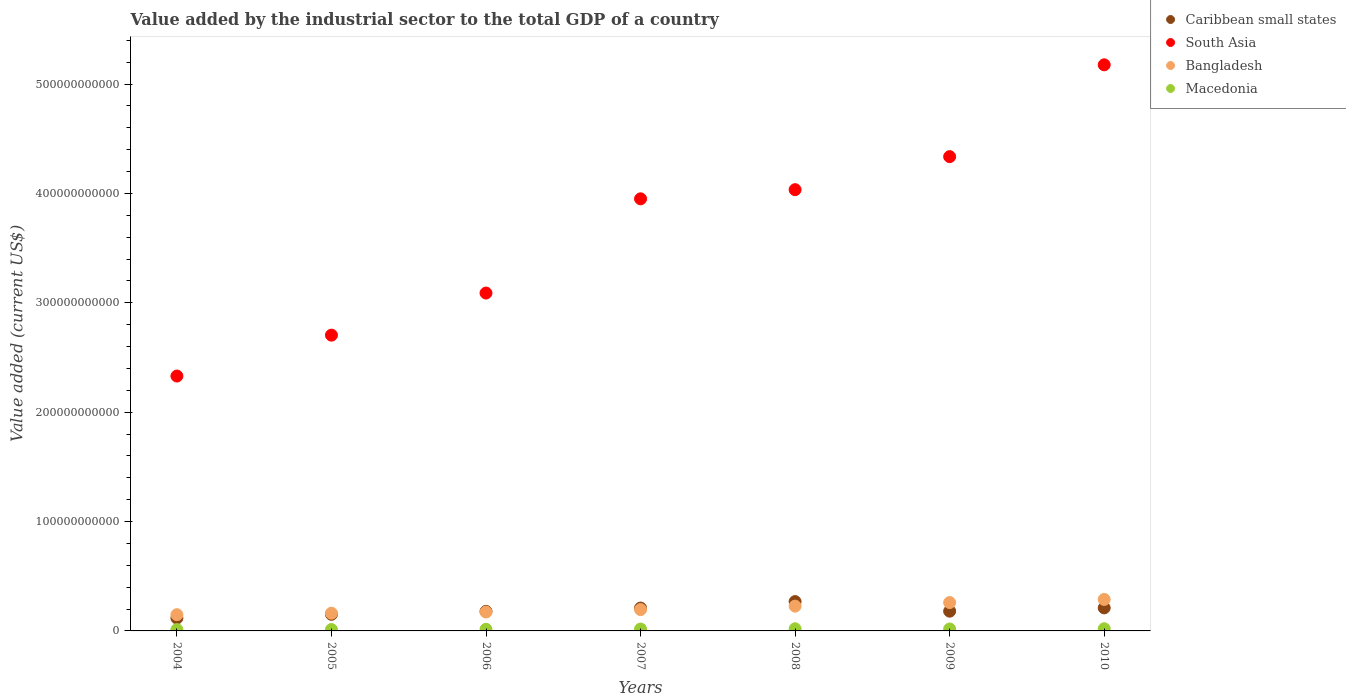Is the number of dotlines equal to the number of legend labels?
Make the answer very short. Yes. What is the value added by the industrial sector to the total GDP in Macedonia in 2007?
Offer a terse response. 1.72e+09. Across all years, what is the maximum value added by the industrial sector to the total GDP in South Asia?
Your answer should be compact. 5.18e+11. Across all years, what is the minimum value added by the industrial sector to the total GDP in Caribbean small states?
Your response must be concise. 1.17e+1. In which year was the value added by the industrial sector to the total GDP in South Asia maximum?
Provide a succinct answer. 2010. What is the total value added by the industrial sector to the total GDP in Bangladesh in the graph?
Your answer should be compact. 1.45e+11. What is the difference between the value added by the industrial sector to the total GDP in Macedonia in 2008 and that in 2010?
Give a very brief answer. -4.39e+07. What is the difference between the value added by the industrial sector to the total GDP in Bangladesh in 2004 and the value added by the industrial sector to the total GDP in Macedonia in 2010?
Ensure brevity in your answer.  1.29e+1. What is the average value added by the industrial sector to the total GDP in Macedonia per year?
Offer a very short reply. 1.62e+09. In the year 2010, what is the difference between the value added by the industrial sector to the total GDP in Macedonia and value added by the industrial sector to the total GDP in South Asia?
Keep it short and to the point. -5.16e+11. What is the ratio of the value added by the industrial sector to the total GDP in Caribbean small states in 2004 to that in 2010?
Ensure brevity in your answer.  0.56. Is the value added by the industrial sector to the total GDP in South Asia in 2004 less than that in 2009?
Provide a short and direct response. Yes. What is the difference between the highest and the second highest value added by the industrial sector to the total GDP in Caribbean small states?
Offer a very short reply. 5.76e+09. What is the difference between the highest and the lowest value added by the industrial sector to the total GDP in Bangladesh?
Provide a succinct answer. 1.39e+1. In how many years, is the value added by the industrial sector to the total GDP in South Asia greater than the average value added by the industrial sector to the total GDP in South Asia taken over all years?
Offer a terse response. 4. Does the value added by the industrial sector to the total GDP in South Asia monotonically increase over the years?
Give a very brief answer. Yes. Is the value added by the industrial sector to the total GDP in Caribbean small states strictly less than the value added by the industrial sector to the total GDP in South Asia over the years?
Make the answer very short. Yes. What is the difference between two consecutive major ticks on the Y-axis?
Your answer should be compact. 1.00e+11. Where does the legend appear in the graph?
Give a very brief answer. Top right. How many legend labels are there?
Your answer should be very brief. 4. What is the title of the graph?
Give a very brief answer. Value added by the industrial sector to the total GDP of a country. What is the label or title of the Y-axis?
Keep it short and to the point. Value added (current US$). What is the Value added (current US$) of Caribbean small states in 2004?
Ensure brevity in your answer.  1.17e+1. What is the Value added (current US$) of South Asia in 2004?
Keep it short and to the point. 2.33e+11. What is the Value added (current US$) in Bangladesh in 2004?
Your answer should be very brief. 1.48e+1. What is the Value added (current US$) of Macedonia in 2004?
Keep it short and to the point. 1.20e+09. What is the Value added (current US$) in Caribbean small states in 2005?
Keep it short and to the point. 1.52e+1. What is the Value added (current US$) of South Asia in 2005?
Your answer should be compact. 2.70e+11. What is the Value added (current US$) of Bangladesh in 2005?
Offer a terse response. 1.62e+1. What is the Value added (current US$) of Macedonia in 2005?
Provide a succinct answer. 1.27e+09. What is the Value added (current US$) in Caribbean small states in 2006?
Offer a terse response. 1.79e+1. What is the Value added (current US$) in South Asia in 2006?
Provide a short and direct response. 3.09e+11. What is the Value added (current US$) of Bangladesh in 2006?
Give a very brief answer. 1.73e+1. What is the Value added (current US$) in Macedonia in 2006?
Keep it short and to the point. 1.49e+09. What is the Value added (current US$) of Caribbean small states in 2007?
Your answer should be very brief. 2.09e+1. What is the Value added (current US$) in South Asia in 2007?
Give a very brief answer. 3.95e+11. What is the Value added (current US$) of Bangladesh in 2007?
Ensure brevity in your answer.  1.95e+1. What is the Value added (current US$) in Macedonia in 2007?
Make the answer very short. 1.72e+09. What is the Value added (current US$) in Caribbean small states in 2008?
Make the answer very short. 2.68e+1. What is the Value added (current US$) of South Asia in 2008?
Ensure brevity in your answer.  4.03e+11. What is the Value added (current US$) in Bangladesh in 2008?
Provide a short and direct response. 2.27e+1. What is the Value added (current US$) of Macedonia in 2008?
Your response must be concise. 1.94e+09. What is the Value added (current US$) in Caribbean small states in 2009?
Ensure brevity in your answer.  1.80e+1. What is the Value added (current US$) in South Asia in 2009?
Offer a terse response. 4.34e+11. What is the Value added (current US$) in Bangladesh in 2009?
Offer a terse response. 2.59e+1. What is the Value added (current US$) of Macedonia in 2009?
Keep it short and to the point. 1.78e+09. What is the Value added (current US$) in Caribbean small states in 2010?
Keep it short and to the point. 2.10e+1. What is the Value added (current US$) in South Asia in 2010?
Provide a short and direct response. 5.18e+11. What is the Value added (current US$) of Bangladesh in 2010?
Keep it short and to the point. 2.88e+1. What is the Value added (current US$) of Macedonia in 2010?
Provide a short and direct response. 1.98e+09. Across all years, what is the maximum Value added (current US$) in Caribbean small states?
Keep it short and to the point. 2.68e+1. Across all years, what is the maximum Value added (current US$) in South Asia?
Your response must be concise. 5.18e+11. Across all years, what is the maximum Value added (current US$) in Bangladesh?
Provide a short and direct response. 2.88e+1. Across all years, what is the maximum Value added (current US$) of Macedonia?
Give a very brief answer. 1.98e+09. Across all years, what is the minimum Value added (current US$) in Caribbean small states?
Provide a succinct answer. 1.17e+1. Across all years, what is the minimum Value added (current US$) in South Asia?
Give a very brief answer. 2.33e+11. Across all years, what is the minimum Value added (current US$) of Bangladesh?
Your response must be concise. 1.48e+1. Across all years, what is the minimum Value added (current US$) in Macedonia?
Offer a terse response. 1.20e+09. What is the total Value added (current US$) of Caribbean small states in the graph?
Your response must be concise. 1.32e+11. What is the total Value added (current US$) of South Asia in the graph?
Offer a very short reply. 2.56e+12. What is the total Value added (current US$) in Bangladesh in the graph?
Offer a very short reply. 1.45e+11. What is the total Value added (current US$) of Macedonia in the graph?
Offer a terse response. 1.14e+1. What is the difference between the Value added (current US$) of Caribbean small states in 2004 and that in 2005?
Your answer should be compact. -3.45e+09. What is the difference between the Value added (current US$) in South Asia in 2004 and that in 2005?
Make the answer very short. -3.74e+1. What is the difference between the Value added (current US$) of Bangladesh in 2004 and that in 2005?
Your answer should be compact. -1.35e+09. What is the difference between the Value added (current US$) of Macedonia in 2004 and that in 2005?
Your answer should be very brief. -7.88e+07. What is the difference between the Value added (current US$) in Caribbean small states in 2004 and that in 2006?
Your answer should be compact. -6.18e+09. What is the difference between the Value added (current US$) in South Asia in 2004 and that in 2006?
Give a very brief answer. -7.59e+1. What is the difference between the Value added (current US$) in Bangladesh in 2004 and that in 2006?
Provide a short and direct response. -2.47e+09. What is the difference between the Value added (current US$) in Macedonia in 2004 and that in 2006?
Your response must be concise. -2.91e+08. What is the difference between the Value added (current US$) of Caribbean small states in 2004 and that in 2007?
Your response must be concise. -9.18e+09. What is the difference between the Value added (current US$) in South Asia in 2004 and that in 2007?
Your answer should be very brief. -1.62e+11. What is the difference between the Value added (current US$) of Bangladesh in 2004 and that in 2007?
Provide a short and direct response. -4.67e+09. What is the difference between the Value added (current US$) of Macedonia in 2004 and that in 2007?
Provide a short and direct response. -5.20e+08. What is the difference between the Value added (current US$) in Caribbean small states in 2004 and that in 2008?
Give a very brief answer. -1.51e+1. What is the difference between the Value added (current US$) in South Asia in 2004 and that in 2008?
Ensure brevity in your answer.  -1.70e+11. What is the difference between the Value added (current US$) in Bangladesh in 2004 and that in 2008?
Keep it short and to the point. -7.83e+09. What is the difference between the Value added (current US$) of Macedonia in 2004 and that in 2008?
Your answer should be compact. -7.40e+08. What is the difference between the Value added (current US$) of Caribbean small states in 2004 and that in 2009?
Offer a very short reply. -6.32e+09. What is the difference between the Value added (current US$) of South Asia in 2004 and that in 2009?
Keep it short and to the point. -2.01e+11. What is the difference between the Value added (current US$) in Bangladesh in 2004 and that in 2009?
Make the answer very short. -1.11e+1. What is the difference between the Value added (current US$) in Macedonia in 2004 and that in 2009?
Give a very brief answer. -5.88e+08. What is the difference between the Value added (current US$) of Caribbean small states in 2004 and that in 2010?
Make the answer very short. -9.32e+09. What is the difference between the Value added (current US$) in South Asia in 2004 and that in 2010?
Your response must be concise. -2.85e+11. What is the difference between the Value added (current US$) of Bangladesh in 2004 and that in 2010?
Your answer should be compact. -1.39e+1. What is the difference between the Value added (current US$) in Macedonia in 2004 and that in 2010?
Offer a very short reply. -7.84e+08. What is the difference between the Value added (current US$) of Caribbean small states in 2005 and that in 2006?
Give a very brief answer. -2.74e+09. What is the difference between the Value added (current US$) in South Asia in 2005 and that in 2006?
Your answer should be very brief. -3.85e+1. What is the difference between the Value added (current US$) of Bangladesh in 2005 and that in 2006?
Your answer should be very brief. -1.12e+09. What is the difference between the Value added (current US$) in Macedonia in 2005 and that in 2006?
Your response must be concise. -2.12e+08. What is the difference between the Value added (current US$) in Caribbean small states in 2005 and that in 2007?
Provide a short and direct response. -5.74e+09. What is the difference between the Value added (current US$) in South Asia in 2005 and that in 2007?
Your answer should be very brief. -1.25e+11. What is the difference between the Value added (current US$) in Bangladesh in 2005 and that in 2007?
Provide a short and direct response. -3.33e+09. What is the difference between the Value added (current US$) in Macedonia in 2005 and that in 2007?
Your response must be concise. -4.41e+08. What is the difference between the Value added (current US$) in Caribbean small states in 2005 and that in 2008?
Your answer should be very brief. -1.16e+1. What is the difference between the Value added (current US$) in South Asia in 2005 and that in 2008?
Give a very brief answer. -1.33e+11. What is the difference between the Value added (current US$) of Bangladesh in 2005 and that in 2008?
Ensure brevity in your answer.  -6.48e+09. What is the difference between the Value added (current US$) of Macedonia in 2005 and that in 2008?
Provide a short and direct response. -6.61e+08. What is the difference between the Value added (current US$) of Caribbean small states in 2005 and that in 2009?
Offer a terse response. -2.87e+09. What is the difference between the Value added (current US$) of South Asia in 2005 and that in 2009?
Your answer should be very brief. -1.63e+11. What is the difference between the Value added (current US$) of Bangladesh in 2005 and that in 2009?
Give a very brief answer. -9.74e+09. What is the difference between the Value added (current US$) of Macedonia in 2005 and that in 2009?
Your response must be concise. -5.09e+08. What is the difference between the Value added (current US$) of Caribbean small states in 2005 and that in 2010?
Make the answer very short. -5.88e+09. What is the difference between the Value added (current US$) of South Asia in 2005 and that in 2010?
Your response must be concise. -2.47e+11. What is the difference between the Value added (current US$) of Bangladesh in 2005 and that in 2010?
Provide a short and direct response. -1.26e+1. What is the difference between the Value added (current US$) of Macedonia in 2005 and that in 2010?
Provide a succinct answer. -7.05e+08. What is the difference between the Value added (current US$) in Caribbean small states in 2006 and that in 2007?
Make the answer very short. -3.00e+09. What is the difference between the Value added (current US$) of South Asia in 2006 and that in 2007?
Make the answer very short. -8.62e+1. What is the difference between the Value added (current US$) of Bangladesh in 2006 and that in 2007?
Give a very brief answer. -2.20e+09. What is the difference between the Value added (current US$) of Macedonia in 2006 and that in 2007?
Give a very brief answer. -2.29e+08. What is the difference between the Value added (current US$) in Caribbean small states in 2006 and that in 2008?
Give a very brief answer. -8.90e+09. What is the difference between the Value added (current US$) of South Asia in 2006 and that in 2008?
Your response must be concise. -9.45e+1. What is the difference between the Value added (current US$) in Bangladesh in 2006 and that in 2008?
Provide a short and direct response. -5.35e+09. What is the difference between the Value added (current US$) in Macedonia in 2006 and that in 2008?
Offer a terse response. -4.49e+08. What is the difference between the Value added (current US$) in Caribbean small states in 2006 and that in 2009?
Give a very brief answer. -1.39e+08. What is the difference between the Value added (current US$) in South Asia in 2006 and that in 2009?
Your response must be concise. -1.25e+11. What is the difference between the Value added (current US$) of Bangladesh in 2006 and that in 2009?
Your answer should be compact. -8.62e+09. What is the difference between the Value added (current US$) in Macedonia in 2006 and that in 2009?
Your answer should be compact. -2.97e+08. What is the difference between the Value added (current US$) in Caribbean small states in 2006 and that in 2010?
Your answer should be very brief. -3.14e+09. What is the difference between the Value added (current US$) of South Asia in 2006 and that in 2010?
Provide a short and direct response. -2.09e+11. What is the difference between the Value added (current US$) of Bangladesh in 2006 and that in 2010?
Offer a very short reply. -1.15e+1. What is the difference between the Value added (current US$) of Macedonia in 2006 and that in 2010?
Offer a very short reply. -4.93e+08. What is the difference between the Value added (current US$) in Caribbean small states in 2007 and that in 2008?
Make the answer very short. -5.90e+09. What is the difference between the Value added (current US$) in South Asia in 2007 and that in 2008?
Ensure brevity in your answer.  -8.36e+09. What is the difference between the Value added (current US$) in Bangladesh in 2007 and that in 2008?
Your response must be concise. -3.15e+09. What is the difference between the Value added (current US$) in Macedonia in 2007 and that in 2008?
Offer a very short reply. -2.20e+08. What is the difference between the Value added (current US$) in Caribbean small states in 2007 and that in 2009?
Your answer should be very brief. 2.86e+09. What is the difference between the Value added (current US$) of South Asia in 2007 and that in 2009?
Offer a terse response. -3.86e+1. What is the difference between the Value added (current US$) of Bangladesh in 2007 and that in 2009?
Offer a terse response. -6.42e+09. What is the difference between the Value added (current US$) in Macedonia in 2007 and that in 2009?
Make the answer very short. -6.80e+07. What is the difference between the Value added (current US$) of Caribbean small states in 2007 and that in 2010?
Make the answer very short. -1.38e+08. What is the difference between the Value added (current US$) of South Asia in 2007 and that in 2010?
Offer a very short reply. -1.23e+11. What is the difference between the Value added (current US$) of Bangladesh in 2007 and that in 2010?
Give a very brief answer. -9.26e+09. What is the difference between the Value added (current US$) of Macedonia in 2007 and that in 2010?
Make the answer very short. -2.64e+08. What is the difference between the Value added (current US$) in Caribbean small states in 2008 and that in 2009?
Ensure brevity in your answer.  8.76e+09. What is the difference between the Value added (current US$) of South Asia in 2008 and that in 2009?
Make the answer very short. -3.02e+1. What is the difference between the Value added (current US$) of Bangladesh in 2008 and that in 2009?
Your answer should be very brief. -3.26e+09. What is the difference between the Value added (current US$) of Macedonia in 2008 and that in 2009?
Keep it short and to the point. 1.52e+08. What is the difference between the Value added (current US$) in Caribbean small states in 2008 and that in 2010?
Your response must be concise. 5.76e+09. What is the difference between the Value added (current US$) of South Asia in 2008 and that in 2010?
Give a very brief answer. -1.14e+11. What is the difference between the Value added (current US$) in Bangladesh in 2008 and that in 2010?
Your answer should be compact. -6.11e+09. What is the difference between the Value added (current US$) in Macedonia in 2008 and that in 2010?
Keep it short and to the point. -4.39e+07. What is the difference between the Value added (current US$) in Caribbean small states in 2009 and that in 2010?
Provide a short and direct response. -3.00e+09. What is the difference between the Value added (current US$) of South Asia in 2009 and that in 2010?
Provide a short and direct response. -8.39e+1. What is the difference between the Value added (current US$) of Bangladesh in 2009 and that in 2010?
Offer a very short reply. -2.85e+09. What is the difference between the Value added (current US$) of Macedonia in 2009 and that in 2010?
Give a very brief answer. -1.96e+08. What is the difference between the Value added (current US$) of Caribbean small states in 2004 and the Value added (current US$) of South Asia in 2005?
Keep it short and to the point. -2.59e+11. What is the difference between the Value added (current US$) of Caribbean small states in 2004 and the Value added (current US$) of Bangladesh in 2005?
Your answer should be very brief. -4.45e+09. What is the difference between the Value added (current US$) in Caribbean small states in 2004 and the Value added (current US$) in Macedonia in 2005?
Offer a very short reply. 1.05e+1. What is the difference between the Value added (current US$) in South Asia in 2004 and the Value added (current US$) in Bangladesh in 2005?
Your answer should be compact. 2.17e+11. What is the difference between the Value added (current US$) in South Asia in 2004 and the Value added (current US$) in Macedonia in 2005?
Your answer should be compact. 2.32e+11. What is the difference between the Value added (current US$) of Bangladesh in 2004 and the Value added (current US$) of Macedonia in 2005?
Keep it short and to the point. 1.36e+1. What is the difference between the Value added (current US$) of Caribbean small states in 2004 and the Value added (current US$) of South Asia in 2006?
Offer a very short reply. -2.97e+11. What is the difference between the Value added (current US$) of Caribbean small states in 2004 and the Value added (current US$) of Bangladesh in 2006?
Keep it short and to the point. -5.58e+09. What is the difference between the Value added (current US$) of Caribbean small states in 2004 and the Value added (current US$) of Macedonia in 2006?
Offer a very short reply. 1.02e+1. What is the difference between the Value added (current US$) of South Asia in 2004 and the Value added (current US$) of Bangladesh in 2006?
Your response must be concise. 2.16e+11. What is the difference between the Value added (current US$) of South Asia in 2004 and the Value added (current US$) of Macedonia in 2006?
Your answer should be very brief. 2.32e+11. What is the difference between the Value added (current US$) in Bangladesh in 2004 and the Value added (current US$) in Macedonia in 2006?
Offer a very short reply. 1.33e+1. What is the difference between the Value added (current US$) of Caribbean small states in 2004 and the Value added (current US$) of South Asia in 2007?
Give a very brief answer. -3.83e+11. What is the difference between the Value added (current US$) in Caribbean small states in 2004 and the Value added (current US$) in Bangladesh in 2007?
Offer a very short reply. -7.78e+09. What is the difference between the Value added (current US$) of Caribbean small states in 2004 and the Value added (current US$) of Macedonia in 2007?
Ensure brevity in your answer.  1.00e+1. What is the difference between the Value added (current US$) of South Asia in 2004 and the Value added (current US$) of Bangladesh in 2007?
Ensure brevity in your answer.  2.14e+11. What is the difference between the Value added (current US$) in South Asia in 2004 and the Value added (current US$) in Macedonia in 2007?
Make the answer very short. 2.31e+11. What is the difference between the Value added (current US$) in Bangladesh in 2004 and the Value added (current US$) in Macedonia in 2007?
Provide a succinct answer. 1.31e+1. What is the difference between the Value added (current US$) of Caribbean small states in 2004 and the Value added (current US$) of South Asia in 2008?
Keep it short and to the point. -3.92e+11. What is the difference between the Value added (current US$) in Caribbean small states in 2004 and the Value added (current US$) in Bangladesh in 2008?
Offer a very short reply. -1.09e+1. What is the difference between the Value added (current US$) in Caribbean small states in 2004 and the Value added (current US$) in Macedonia in 2008?
Provide a short and direct response. 9.79e+09. What is the difference between the Value added (current US$) in South Asia in 2004 and the Value added (current US$) in Bangladesh in 2008?
Ensure brevity in your answer.  2.10e+11. What is the difference between the Value added (current US$) in South Asia in 2004 and the Value added (current US$) in Macedonia in 2008?
Offer a very short reply. 2.31e+11. What is the difference between the Value added (current US$) in Bangladesh in 2004 and the Value added (current US$) in Macedonia in 2008?
Provide a succinct answer. 1.29e+1. What is the difference between the Value added (current US$) in Caribbean small states in 2004 and the Value added (current US$) in South Asia in 2009?
Keep it short and to the point. -4.22e+11. What is the difference between the Value added (current US$) of Caribbean small states in 2004 and the Value added (current US$) of Bangladesh in 2009?
Offer a very short reply. -1.42e+1. What is the difference between the Value added (current US$) of Caribbean small states in 2004 and the Value added (current US$) of Macedonia in 2009?
Make the answer very short. 9.94e+09. What is the difference between the Value added (current US$) in South Asia in 2004 and the Value added (current US$) in Bangladesh in 2009?
Ensure brevity in your answer.  2.07e+11. What is the difference between the Value added (current US$) in South Asia in 2004 and the Value added (current US$) in Macedonia in 2009?
Provide a short and direct response. 2.31e+11. What is the difference between the Value added (current US$) in Bangladesh in 2004 and the Value added (current US$) in Macedonia in 2009?
Keep it short and to the point. 1.30e+1. What is the difference between the Value added (current US$) in Caribbean small states in 2004 and the Value added (current US$) in South Asia in 2010?
Ensure brevity in your answer.  -5.06e+11. What is the difference between the Value added (current US$) of Caribbean small states in 2004 and the Value added (current US$) of Bangladesh in 2010?
Keep it short and to the point. -1.70e+1. What is the difference between the Value added (current US$) in Caribbean small states in 2004 and the Value added (current US$) in Macedonia in 2010?
Provide a short and direct response. 9.75e+09. What is the difference between the Value added (current US$) of South Asia in 2004 and the Value added (current US$) of Bangladesh in 2010?
Make the answer very short. 2.04e+11. What is the difference between the Value added (current US$) of South Asia in 2004 and the Value added (current US$) of Macedonia in 2010?
Ensure brevity in your answer.  2.31e+11. What is the difference between the Value added (current US$) in Bangladesh in 2004 and the Value added (current US$) in Macedonia in 2010?
Provide a short and direct response. 1.29e+1. What is the difference between the Value added (current US$) in Caribbean small states in 2005 and the Value added (current US$) in South Asia in 2006?
Your answer should be compact. -2.94e+11. What is the difference between the Value added (current US$) in Caribbean small states in 2005 and the Value added (current US$) in Bangladesh in 2006?
Provide a short and direct response. -2.13e+09. What is the difference between the Value added (current US$) of Caribbean small states in 2005 and the Value added (current US$) of Macedonia in 2006?
Ensure brevity in your answer.  1.37e+1. What is the difference between the Value added (current US$) in South Asia in 2005 and the Value added (current US$) in Bangladesh in 2006?
Offer a very short reply. 2.53e+11. What is the difference between the Value added (current US$) in South Asia in 2005 and the Value added (current US$) in Macedonia in 2006?
Your response must be concise. 2.69e+11. What is the difference between the Value added (current US$) of Bangladesh in 2005 and the Value added (current US$) of Macedonia in 2006?
Your answer should be very brief. 1.47e+1. What is the difference between the Value added (current US$) of Caribbean small states in 2005 and the Value added (current US$) of South Asia in 2007?
Offer a very short reply. -3.80e+11. What is the difference between the Value added (current US$) in Caribbean small states in 2005 and the Value added (current US$) in Bangladesh in 2007?
Make the answer very short. -4.33e+09. What is the difference between the Value added (current US$) of Caribbean small states in 2005 and the Value added (current US$) of Macedonia in 2007?
Make the answer very short. 1.35e+1. What is the difference between the Value added (current US$) in South Asia in 2005 and the Value added (current US$) in Bangladesh in 2007?
Provide a succinct answer. 2.51e+11. What is the difference between the Value added (current US$) in South Asia in 2005 and the Value added (current US$) in Macedonia in 2007?
Keep it short and to the point. 2.69e+11. What is the difference between the Value added (current US$) of Bangladesh in 2005 and the Value added (current US$) of Macedonia in 2007?
Your response must be concise. 1.45e+1. What is the difference between the Value added (current US$) in Caribbean small states in 2005 and the Value added (current US$) in South Asia in 2008?
Ensure brevity in your answer.  -3.88e+11. What is the difference between the Value added (current US$) in Caribbean small states in 2005 and the Value added (current US$) in Bangladesh in 2008?
Your answer should be compact. -7.48e+09. What is the difference between the Value added (current US$) in Caribbean small states in 2005 and the Value added (current US$) in Macedonia in 2008?
Make the answer very short. 1.32e+1. What is the difference between the Value added (current US$) in South Asia in 2005 and the Value added (current US$) in Bangladesh in 2008?
Provide a short and direct response. 2.48e+11. What is the difference between the Value added (current US$) in South Asia in 2005 and the Value added (current US$) in Macedonia in 2008?
Offer a terse response. 2.68e+11. What is the difference between the Value added (current US$) of Bangladesh in 2005 and the Value added (current US$) of Macedonia in 2008?
Your answer should be very brief. 1.42e+1. What is the difference between the Value added (current US$) of Caribbean small states in 2005 and the Value added (current US$) of South Asia in 2009?
Your response must be concise. -4.18e+11. What is the difference between the Value added (current US$) of Caribbean small states in 2005 and the Value added (current US$) of Bangladesh in 2009?
Your response must be concise. -1.07e+1. What is the difference between the Value added (current US$) of Caribbean small states in 2005 and the Value added (current US$) of Macedonia in 2009?
Your response must be concise. 1.34e+1. What is the difference between the Value added (current US$) of South Asia in 2005 and the Value added (current US$) of Bangladesh in 2009?
Your answer should be very brief. 2.44e+11. What is the difference between the Value added (current US$) in South Asia in 2005 and the Value added (current US$) in Macedonia in 2009?
Provide a short and direct response. 2.69e+11. What is the difference between the Value added (current US$) of Bangladesh in 2005 and the Value added (current US$) of Macedonia in 2009?
Provide a short and direct response. 1.44e+1. What is the difference between the Value added (current US$) of Caribbean small states in 2005 and the Value added (current US$) of South Asia in 2010?
Make the answer very short. -5.02e+11. What is the difference between the Value added (current US$) of Caribbean small states in 2005 and the Value added (current US$) of Bangladesh in 2010?
Give a very brief answer. -1.36e+1. What is the difference between the Value added (current US$) in Caribbean small states in 2005 and the Value added (current US$) in Macedonia in 2010?
Provide a short and direct response. 1.32e+1. What is the difference between the Value added (current US$) in South Asia in 2005 and the Value added (current US$) in Bangladesh in 2010?
Keep it short and to the point. 2.42e+11. What is the difference between the Value added (current US$) of South Asia in 2005 and the Value added (current US$) of Macedonia in 2010?
Offer a very short reply. 2.68e+11. What is the difference between the Value added (current US$) of Bangladesh in 2005 and the Value added (current US$) of Macedonia in 2010?
Offer a terse response. 1.42e+1. What is the difference between the Value added (current US$) of Caribbean small states in 2006 and the Value added (current US$) of South Asia in 2007?
Offer a very short reply. -3.77e+11. What is the difference between the Value added (current US$) of Caribbean small states in 2006 and the Value added (current US$) of Bangladesh in 2007?
Offer a terse response. -1.60e+09. What is the difference between the Value added (current US$) of Caribbean small states in 2006 and the Value added (current US$) of Macedonia in 2007?
Make the answer very short. 1.62e+1. What is the difference between the Value added (current US$) in South Asia in 2006 and the Value added (current US$) in Bangladesh in 2007?
Give a very brief answer. 2.89e+11. What is the difference between the Value added (current US$) of South Asia in 2006 and the Value added (current US$) of Macedonia in 2007?
Offer a very short reply. 3.07e+11. What is the difference between the Value added (current US$) of Bangladesh in 2006 and the Value added (current US$) of Macedonia in 2007?
Make the answer very short. 1.56e+1. What is the difference between the Value added (current US$) in Caribbean small states in 2006 and the Value added (current US$) in South Asia in 2008?
Your answer should be very brief. -3.85e+11. What is the difference between the Value added (current US$) in Caribbean small states in 2006 and the Value added (current US$) in Bangladesh in 2008?
Offer a very short reply. -4.75e+09. What is the difference between the Value added (current US$) in Caribbean small states in 2006 and the Value added (current US$) in Macedonia in 2008?
Your answer should be compact. 1.60e+1. What is the difference between the Value added (current US$) of South Asia in 2006 and the Value added (current US$) of Bangladesh in 2008?
Your answer should be very brief. 2.86e+11. What is the difference between the Value added (current US$) of South Asia in 2006 and the Value added (current US$) of Macedonia in 2008?
Your answer should be very brief. 3.07e+11. What is the difference between the Value added (current US$) of Bangladesh in 2006 and the Value added (current US$) of Macedonia in 2008?
Your answer should be very brief. 1.54e+1. What is the difference between the Value added (current US$) in Caribbean small states in 2006 and the Value added (current US$) in South Asia in 2009?
Make the answer very short. -4.16e+11. What is the difference between the Value added (current US$) of Caribbean small states in 2006 and the Value added (current US$) of Bangladesh in 2009?
Make the answer very short. -8.01e+09. What is the difference between the Value added (current US$) in Caribbean small states in 2006 and the Value added (current US$) in Macedonia in 2009?
Keep it short and to the point. 1.61e+1. What is the difference between the Value added (current US$) in South Asia in 2006 and the Value added (current US$) in Bangladesh in 2009?
Your answer should be compact. 2.83e+11. What is the difference between the Value added (current US$) in South Asia in 2006 and the Value added (current US$) in Macedonia in 2009?
Your answer should be compact. 3.07e+11. What is the difference between the Value added (current US$) of Bangladesh in 2006 and the Value added (current US$) of Macedonia in 2009?
Keep it short and to the point. 1.55e+1. What is the difference between the Value added (current US$) in Caribbean small states in 2006 and the Value added (current US$) in South Asia in 2010?
Your answer should be compact. -5.00e+11. What is the difference between the Value added (current US$) of Caribbean small states in 2006 and the Value added (current US$) of Bangladesh in 2010?
Your answer should be compact. -1.09e+1. What is the difference between the Value added (current US$) in Caribbean small states in 2006 and the Value added (current US$) in Macedonia in 2010?
Make the answer very short. 1.59e+1. What is the difference between the Value added (current US$) of South Asia in 2006 and the Value added (current US$) of Bangladesh in 2010?
Your answer should be very brief. 2.80e+11. What is the difference between the Value added (current US$) of South Asia in 2006 and the Value added (current US$) of Macedonia in 2010?
Ensure brevity in your answer.  3.07e+11. What is the difference between the Value added (current US$) in Bangladesh in 2006 and the Value added (current US$) in Macedonia in 2010?
Ensure brevity in your answer.  1.53e+1. What is the difference between the Value added (current US$) in Caribbean small states in 2007 and the Value added (current US$) in South Asia in 2008?
Ensure brevity in your answer.  -3.82e+11. What is the difference between the Value added (current US$) of Caribbean small states in 2007 and the Value added (current US$) of Bangladesh in 2008?
Your response must be concise. -1.75e+09. What is the difference between the Value added (current US$) in Caribbean small states in 2007 and the Value added (current US$) in Macedonia in 2008?
Provide a short and direct response. 1.90e+1. What is the difference between the Value added (current US$) in South Asia in 2007 and the Value added (current US$) in Bangladesh in 2008?
Offer a very short reply. 3.72e+11. What is the difference between the Value added (current US$) in South Asia in 2007 and the Value added (current US$) in Macedonia in 2008?
Give a very brief answer. 3.93e+11. What is the difference between the Value added (current US$) in Bangladesh in 2007 and the Value added (current US$) in Macedonia in 2008?
Provide a succinct answer. 1.76e+1. What is the difference between the Value added (current US$) of Caribbean small states in 2007 and the Value added (current US$) of South Asia in 2009?
Your answer should be compact. -4.13e+11. What is the difference between the Value added (current US$) of Caribbean small states in 2007 and the Value added (current US$) of Bangladesh in 2009?
Make the answer very short. -5.01e+09. What is the difference between the Value added (current US$) of Caribbean small states in 2007 and the Value added (current US$) of Macedonia in 2009?
Your response must be concise. 1.91e+1. What is the difference between the Value added (current US$) of South Asia in 2007 and the Value added (current US$) of Bangladesh in 2009?
Offer a terse response. 3.69e+11. What is the difference between the Value added (current US$) in South Asia in 2007 and the Value added (current US$) in Macedonia in 2009?
Offer a terse response. 3.93e+11. What is the difference between the Value added (current US$) in Bangladesh in 2007 and the Value added (current US$) in Macedonia in 2009?
Provide a succinct answer. 1.77e+1. What is the difference between the Value added (current US$) of Caribbean small states in 2007 and the Value added (current US$) of South Asia in 2010?
Provide a succinct answer. -4.97e+11. What is the difference between the Value added (current US$) in Caribbean small states in 2007 and the Value added (current US$) in Bangladesh in 2010?
Your response must be concise. -7.86e+09. What is the difference between the Value added (current US$) of Caribbean small states in 2007 and the Value added (current US$) of Macedonia in 2010?
Your answer should be compact. 1.89e+1. What is the difference between the Value added (current US$) of South Asia in 2007 and the Value added (current US$) of Bangladesh in 2010?
Offer a very short reply. 3.66e+11. What is the difference between the Value added (current US$) of South Asia in 2007 and the Value added (current US$) of Macedonia in 2010?
Offer a very short reply. 3.93e+11. What is the difference between the Value added (current US$) of Bangladesh in 2007 and the Value added (current US$) of Macedonia in 2010?
Provide a succinct answer. 1.75e+1. What is the difference between the Value added (current US$) in Caribbean small states in 2008 and the Value added (current US$) in South Asia in 2009?
Give a very brief answer. -4.07e+11. What is the difference between the Value added (current US$) in Caribbean small states in 2008 and the Value added (current US$) in Bangladesh in 2009?
Offer a terse response. 8.88e+08. What is the difference between the Value added (current US$) of Caribbean small states in 2008 and the Value added (current US$) of Macedonia in 2009?
Provide a short and direct response. 2.50e+1. What is the difference between the Value added (current US$) of South Asia in 2008 and the Value added (current US$) of Bangladesh in 2009?
Your answer should be very brief. 3.77e+11. What is the difference between the Value added (current US$) of South Asia in 2008 and the Value added (current US$) of Macedonia in 2009?
Give a very brief answer. 4.02e+11. What is the difference between the Value added (current US$) of Bangladesh in 2008 and the Value added (current US$) of Macedonia in 2009?
Make the answer very short. 2.09e+1. What is the difference between the Value added (current US$) of Caribbean small states in 2008 and the Value added (current US$) of South Asia in 2010?
Keep it short and to the point. -4.91e+11. What is the difference between the Value added (current US$) in Caribbean small states in 2008 and the Value added (current US$) in Bangladesh in 2010?
Your answer should be compact. -1.96e+09. What is the difference between the Value added (current US$) in Caribbean small states in 2008 and the Value added (current US$) in Macedonia in 2010?
Offer a terse response. 2.48e+1. What is the difference between the Value added (current US$) of South Asia in 2008 and the Value added (current US$) of Bangladesh in 2010?
Give a very brief answer. 3.75e+11. What is the difference between the Value added (current US$) of South Asia in 2008 and the Value added (current US$) of Macedonia in 2010?
Offer a terse response. 4.01e+11. What is the difference between the Value added (current US$) in Bangladesh in 2008 and the Value added (current US$) in Macedonia in 2010?
Provide a succinct answer. 2.07e+1. What is the difference between the Value added (current US$) in Caribbean small states in 2009 and the Value added (current US$) in South Asia in 2010?
Provide a short and direct response. -4.99e+11. What is the difference between the Value added (current US$) of Caribbean small states in 2009 and the Value added (current US$) of Bangladesh in 2010?
Make the answer very short. -1.07e+1. What is the difference between the Value added (current US$) of Caribbean small states in 2009 and the Value added (current US$) of Macedonia in 2010?
Keep it short and to the point. 1.61e+1. What is the difference between the Value added (current US$) of South Asia in 2009 and the Value added (current US$) of Bangladesh in 2010?
Your response must be concise. 4.05e+11. What is the difference between the Value added (current US$) in South Asia in 2009 and the Value added (current US$) in Macedonia in 2010?
Offer a terse response. 4.32e+11. What is the difference between the Value added (current US$) in Bangladesh in 2009 and the Value added (current US$) in Macedonia in 2010?
Your answer should be compact. 2.39e+1. What is the average Value added (current US$) of Caribbean small states per year?
Offer a very short reply. 1.88e+1. What is the average Value added (current US$) of South Asia per year?
Provide a short and direct response. 3.66e+11. What is the average Value added (current US$) in Bangladesh per year?
Your answer should be very brief. 2.07e+1. What is the average Value added (current US$) in Macedonia per year?
Offer a very short reply. 1.62e+09. In the year 2004, what is the difference between the Value added (current US$) of Caribbean small states and Value added (current US$) of South Asia?
Provide a short and direct response. -2.21e+11. In the year 2004, what is the difference between the Value added (current US$) in Caribbean small states and Value added (current US$) in Bangladesh?
Give a very brief answer. -3.10e+09. In the year 2004, what is the difference between the Value added (current US$) in Caribbean small states and Value added (current US$) in Macedonia?
Make the answer very short. 1.05e+1. In the year 2004, what is the difference between the Value added (current US$) in South Asia and Value added (current US$) in Bangladesh?
Your response must be concise. 2.18e+11. In the year 2004, what is the difference between the Value added (current US$) in South Asia and Value added (current US$) in Macedonia?
Provide a succinct answer. 2.32e+11. In the year 2004, what is the difference between the Value added (current US$) of Bangladesh and Value added (current US$) of Macedonia?
Your answer should be very brief. 1.36e+1. In the year 2005, what is the difference between the Value added (current US$) in Caribbean small states and Value added (current US$) in South Asia?
Your answer should be compact. -2.55e+11. In the year 2005, what is the difference between the Value added (current US$) in Caribbean small states and Value added (current US$) in Bangladesh?
Your response must be concise. -1.01e+09. In the year 2005, what is the difference between the Value added (current US$) in Caribbean small states and Value added (current US$) in Macedonia?
Your answer should be compact. 1.39e+1. In the year 2005, what is the difference between the Value added (current US$) of South Asia and Value added (current US$) of Bangladesh?
Your response must be concise. 2.54e+11. In the year 2005, what is the difference between the Value added (current US$) in South Asia and Value added (current US$) in Macedonia?
Make the answer very short. 2.69e+11. In the year 2005, what is the difference between the Value added (current US$) of Bangladesh and Value added (current US$) of Macedonia?
Give a very brief answer. 1.49e+1. In the year 2006, what is the difference between the Value added (current US$) of Caribbean small states and Value added (current US$) of South Asia?
Your answer should be very brief. -2.91e+11. In the year 2006, what is the difference between the Value added (current US$) of Caribbean small states and Value added (current US$) of Bangladesh?
Provide a succinct answer. 6.04e+08. In the year 2006, what is the difference between the Value added (current US$) of Caribbean small states and Value added (current US$) of Macedonia?
Offer a terse response. 1.64e+1. In the year 2006, what is the difference between the Value added (current US$) of South Asia and Value added (current US$) of Bangladesh?
Make the answer very short. 2.92e+11. In the year 2006, what is the difference between the Value added (current US$) in South Asia and Value added (current US$) in Macedonia?
Ensure brevity in your answer.  3.07e+11. In the year 2006, what is the difference between the Value added (current US$) in Bangladesh and Value added (current US$) in Macedonia?
Offer a terse response. 1.58e+1. In the year 2007, what is the difference between the Value added (current US$) in Caribbean small states and Value added (current US$) in South Asia?
Your answer should be very brief. -3.74e+11. In the year 2007, what is the difference between the Value added (current US$) in Caribbean small states and Value added (current US$) in Bangladesh?
Give a very brief answer. 1.41e+09. In the year 2007, what is the difference between the Value added (current US$) of Caribbean small states and Value added (current US$) of Macedonia?
Offer a terse response. 1.92e+1. In the year 2007, what is the difference between the Value added (current US$) in South Asia and Value added (current US$) in Bangladesh?
Make the answer very short. 3.76e+11. In the year 2007, what is the difference between the Value added (current US$) in South Asia and Value added (current US$) in Macedonia?
Make the answer very short. 3.93e+11. In the year 2007, what is the difference between the Value added (current US$) of Bangladesh and Value added (current US$) of Macedonia?
Your answer should be very brief. 1.78e+1. In the year 2008, what is the difference between the Value added (current US$) in Caribbean small states and Value added (current US$) in South Asia?
Give a very brief answer. -3.77e+11. In the year 2008, what is the difference between the Value added (current US$) of Caribbean small states and Value added (current US$) of Bangladesh?
Make the answer very short. 4.15e+09. In the year 2008, what is the difference between the Value added (current US$) of Caribbean small states and Value added (current US$) of Macedonia?
Provide a succinct answer. 2.49e+1. In the year 2008, what is the difference between the Value added (current US$) of South Asia and Value added (current US$) of Bangladesh?
Provide a short and direct response. 3.81e+11. In the year 2008, what is the difference between the Value added (current US$) in South Asia and Value added (current US$) in Macedonia?
Your response must be concise. 4.01e+11. In the year 2008, what is the difference between the Value added (current US$) in Bangladesh and Value added (current US$) in Macedonia?
Make the answer very short. 2.07e+1. In the year 2009, what is the difference between the Value added (current US$) in Caribbean small states and Value added (current US$) in South Asia?
Ensure brevity in your answer.  -4.16e+11. In the year 2009, what is the difference between the Value added (current US$) of Caribbean small states and Value added (current US$) of Bangladesh?
Offer a very short reply. -7.87e+09. In the year 2009, what is the difference between the Value added (current US$) in Caribbean small states and Value added (current US$) in Macedonia?
Give a very brief answer. 1.63e+1. In the year 2009, what is the difference between the Value added (current US$) in South Asia and Value added (current US$) in Bangladesh?
Offer a very short reply. 4.08e+11. In the year 2009, what is the difference between the Value added (current US$) in South Asia and Value added (current US$) in Macedonia?
Keep it short and to the point. 4.32e+11. In the year 2009, what is the difference between the Value added (current US$) of Bangladesh and Value added (current US$) of Macedonia?
Provide a succinct answer. 2.41e+1. In the year 2010, what is the difference between the Value added (current US$) in Caribbean small states and Value added (current US$) in South Asia?
Provide a succinct answer. -4.96e+11. In the year 2010, what is the difference between the Value added (current US$) of Caribbean small states and Value added (current US$) of Bangladesh?
Your response must be concise. -7.72e+09. In the year 2010, what is the difference between the Value added (current US$) in Caribbean small states and Value added (current US$) in Macedonia?
Give a very brief answer. 1.91e+1. In the year 2010, what is the difference between the Value added (current US$) of South Asia and Value added (current US$) of Bangladesh?
Offer a very short reply. 4.89e+11. In the year 2010, what is the difference between the Value added (current US$) in South Asia and Value added (current US$) in Macedonia?
Your answer should be very brief. 5.16e+11. In the year 2010, what is the difference between the Value added (current US$) of Bangladesh and Value added (current US$) of Macedonia?
Your answer should be compact. 2.68e+1. What is the ratio of the Value added (current US$) of Caribbean small states in 2004 to that in 2005?
Make the answer very short. 0.77. What is the ratio of the Value added (current US$) of South Asia in 2004 to that in 2005?
Provide a succinct answer. 0.86. What is the ratio of the Value added (current US$) of Bangladesh in 2004 to that in 2005?
Your response must be concise. 0.92. What is the ratio of the Value added (current US$) of Macedonia in 2004 to that in 2005?
Give a very brief answer. 0.94. What is the ratio of the Value added (current US$) in Caribbean small states in 2004 to that in 2006?
Your response must be concise. 0.65. What is the ratio of the Value added (current US$) of South Asia in 2004 to that in 2006?
Keep it short and to the point. 0.75. What is the ratio of the Value added (current US$) of Bangladesh in 2004 to that in 2006?
Offer a very short reply. 0.86. What is the ratio of the Value added (current US$) of Macedonia in 2004 to that in 2006?
Provide a short and direct response. 0.8. What is the ratio of the Value added (current US$) in Caribbean small states in 2004 to that in 2007?
Keep it short and to the point. 0.56. What is the ratio of the Value added (current US$) of South Asia in 2004 to that in 2007?
Make the answer very short. 0.59. What is the ratio of the Value added (current US$) in Bangladesh in 2004 to that in 2007?
Your answer should be compact. 0.76. What is the ratio of the Value added (current US$) of Macedonia in 2004 to that in 2007?
Ensure brevity in your answer.  0.7. What is the ratio of the Value added (current US$) of Caribbean small states in 2004 to that in 2008?
Your answer should be compact. 0.44. What is the ratio of the Value added (current US$) of South Asia in 2004 to that in 2008?
Make the answer very short. 0.58. What is the ratio of the Value added (current US$) in Bangladesh in 2004 to that in 2008?
Your answer should be very brief. 0.65. What is the ratio of the Value added (current US$) in Macedonia in 2004 to that in 2008?
Your response must be concise. 0.62. What is the ratio of the Value added (current US$) of Caribbean small states in 2004 to that in 2009?
Offer a very short reply. 0.65. What is the ratio of the Value added (current US$) in South Asia in 2004 to that in 2009?
Give a very brief answer. 0.54. What is the ratio of the Value added (current US$) of Bangladesh in 2004 to that in 2009?
Provide a short and direct response. 0.57. What is the ratio of the Value added (current US$) of Macedonia in 2004 to that in 2009?
Keep it short and to the point. 0.67. What is the ratio of the Value added (current US$) of Caribbean small states in 2004 to that in 2010?
Give a very brief answer. 0.56. What is the ratio of the Value added (current US$) of South Asia in 2004 to that in 2010?
Ensure brevity in your answer.  0.45. What is the ratio of the Value added (current US$) of Bangladesh in 2004 to that in 2010?
Your answer should be compact. 0.52. What is the ratio of the Value added (current US$) in Macedonia in 2004 to that in 2010?
Keep it short and to the point. 0.6. What is the ratio of the Value added (current US$) in Caribbean small states in 2005 to that in 2006?
Provide a succinct answer. 0.85. What is the ratio of the Value added (current US$) in South Asia in 2005 to that in 2006?
Your response must be concise. 0.88. What is the ratio of the Value added (current US$) of Bangladesh in 2005 to that in 2006?
Your answer should be very brief. 0.94. What is the ratio of the Value added (current US$) in Macedonia in 2005 to that in 2006?
Keep it short and to the point. 0.86. What is the ratio of the Value added (current US$) of Caribbean small states in 2005 to that in 2007?
Ensure brevity in your answer.  0.73. What is the ratio of the Value added (current US$) in South Asia in 2005 to that in 2007?
Keep it short and to the point. 0.68. What is the ratio of the Value added (current US$) in Bangladesh in 2005 to that in 2007?
Provide a short and direct response. 0.83. What is the ratio of the Value added (current US$) in Macedonia in 2005 to that in 2007?
Provide a succinct answer. 0.74. What is the ratio of the Value added (current US$) of Caribbean small states in 2005 to that in 2008?
Offer a very short reply. 0.57. What is the ratio of the Value added (current US$) in South Asia in 2005 to that in 2008?
Make the answer very short. 0.67. What is the ratio of the Value added (current US$) in Bangladesh in 2005 to that in 2008?
Your answer should be very brief. 0.71. What is the ratio of the Value added (current US$) in Macedonia in 2005 to that in 2008?
Offer a very short reply. 0.66. What is the ratio of the Value added (current US$) of Caribbean small states in 2005 to that in 2009?
Your answer should be very brief. 0.84. What is the ratio of the Value added (current US$) in South Asia in 2005 to that in 2009?
Your answer should be very brief. 0.62. What is the ratio of the Value added (current US$) in Bangladesh in 2005 to that in 2009?
Provide a succinct answer. 0.62. What is the ratio of the Value added (current US$) in Macedonia in 2005 to that in 2009?
Your answer should be compact. 0.71. What is the ratio of the Value added (current US$) in Caribbean small states in 2005 to that in 2010?
Make the answer very short. 0.72. What is the ratio of the Value added (current US$) in South Asia in 2005 to that in 2010?
Your answer should be compact. 0.52. What is the ratio of the Value added (current US$) in Bangladesh in 2005 to that in 2010?
Ensure brevity in your answer.  0.56. What is the ratio of the Value added (current US$) of Macedonia in 2005 to that in 2010?
Your answer should be compact. 0.64. What is the ratio of the Value added (current US$) of Caribbean small states in 2006 to that in 2007?
Ensure brevity in your answer.  0.86. What is the ratio of the Value added (current US$) of South Asia in 2006 to that in 2007?
Keep it short and to the point. 0.78. What is the ratio of the Value added (current US$) of Bangladesh in 2006 to that in 2007?
Offer a terse response. 0.89. What is the ratio of the Value added (current US$) of Macedonia in 2006 to that in 2007?
Ensure brevity in your answer.  0.87. What is the ratio of the Value added (current US$) of Caribbean small states in 2006 to that in 2008?
Make the answer very short. 0.67. What is the ratio of the Value added (current US$) of South Asia in 2006 to that in 2008?
Offer a terse response. 0.77. What is the ratio of the Value added (current US$) in Bangladesh in 2006 to that in 2008?
Ensure brevity in your answer.  0.76. What is the ratio of the Value added (current US$) in Macedonia in 2006 to that in 2008?
Provide a succinct answer. 0.77. What is the ratio of the Value added (current US$) in South Asia in 2006 to that in 2009?
Give a very brief answer. 0.71. What is the ratio of the Value added (current US$) of Bangladesh in 2006 to that in 2009?
Offer a very short reply. 0.67. What is the ratio of the Value added (current US$) in Macedonia in 2006 to that in 2009?
Ensure brevity in your answer.  0.83. What is the ratio of the Value added (current US$) of Caribbean small states in 2006 to that in 2010?
Your answer should be very brief. 0.85. What is the ratio of the Value added (current US$) of South Asia in 2006 to that in 2010?
Provide a succinct answer. 0.6. What is the ratio of the Value added (current US$) of Bangladesh in 2006 to that in 2010?
Ensure brevity in your answer.  0.6. What is the ratio of the Value added (current US$) of Macedonia in 2006 to that in 2010?
Provide a short and direct response. 0.75. What is the ratio of the Value added (current US$) in Caribbean small states in 2007 to that in 2008?
Give a very brief answer. 0.78. What is the ratio of the Value added (current US$) of South Asia in 2007 to that in 2008?
Provide a short and direct response. 0.98. What is the ratio of the Value added (current US$) of Bangladesh in 2007 to that in 2008?
Give a very brief answer. 0.86. What is the ratio of the Value added (current US$) of Macedonia in 2007 to that in 2008?
Your answer should be very brief. 0.89. What is the ratio of the Value added (current US$) of Caribbean small states in 2007 to that in 2009?
Offer a very short reply. 1.16. What is the ratio of the Value added (current US$) in South Asia in 2007 to that in 2009?
Your response must be concise. 0.91. What is the ratio of the Value added (current US$) of Bangladesh in 2007 to that in 2009?
Ensure brevity in your answer.  0.75. What is the ratio of the Value added (current US$) in Macedonia in 2007 to that in 2009?
Give a very brief answer. 0.96. What is the ratio of the Value added (current US$) of South Asia in 2007 to that in 2010?
Ensure brevity in your answer.  0.76. What is the ratio of the Value added (current US$) of Bangladesh in 2007 to that in 2010?
Make the answer very short. 0.68. What is the ratio of the Value added (current US$) in Macedonia in 2007 to that in 2010?
Your answer should be compact. 0.87. What is the ratio of the Value added (current US$) in Caribbean small states in 2008 to that in 2009?
Provide a succinct answer. 1.49. What is the ratio of the Value added (current US$) of South Asia in 2008 to that in 2009?
Make the answer very short. 0.93. What is the ratio of the Value added (current US$) of Bangladesh in 2008 to that in 2009?
Make the answer very short. 0.87. What is the ratio of the Value added (current US$) of Macedonia in 2008 to that in 2009?
Make the answer very short. 1.09. What is the ratio of the Value added (current US$) of Caribbean small states in 2008 to that in 2010?
Your answer should be compact. 1.27. What is the ratio of the Value added (current US$) of South Asia in 2008 to that in 2010?
Provide a short and direct response. 0.78. What is the ratio of the Value added (current US$) of Bangladesh in 2008 to that in 2010?
Keep it short and to the point. 0.79. What is the ratio of the Value added (current US$) in Macedonia in 2008 to that in 2010?
Make the answer very short. 0.98. What is the ratio of the Value added (current US$) in Caribbean small states in 2009 to that in 2010?
Offer a terse response. 0.86. What is the ratio of the Value added (current US$) of South Asia in 2009 to that in 2010?
Provide a short and direct response. 0.84. What is the ratio of the Value added (current US$) of Bangladesh in 2009 to that in 2010?
Your answer should be very brief. 0.9. What is the ratio of the Value added (current US$) of Macedonia in 2009 to that in 2010?
Provide a short and direct response. 0.9. What is the difference between the highest and the second highest Value added (current US$) of Caribbean small states?
Your response must be concise. 5.76e+09. What is the difference between the highest and the second highest Value added (current US$) in South Asia?
Provide a succinct answer. 8.39e+1. What is the difference between the highest and the second highest Value added (current US$) of Bangladesh?
Make the answer very short. 2.85e+09. What is the difference between the highest and the second highest Value added (current US$) of Macedonia?
Provide a short and direct response. 4.39e+07. What is the difference between the highest and the lowest Value added (current US$) of Caribbean small states?
Give a very brief answer. 1.51e+1. What is the difference between the highest and the lowest Value added (current US$) of South Asia?
Ensure brevity in your answer.  2.85e+11. What is the difference between the highest and the lowest Value added (current US$) in Bangladesh?
Ensure brevity in your answer.  1.39e+1. What is the difference between the highest and the lowest Value added (current US$) of Macedonia?
Offer a terse response. 7.84e+08. 